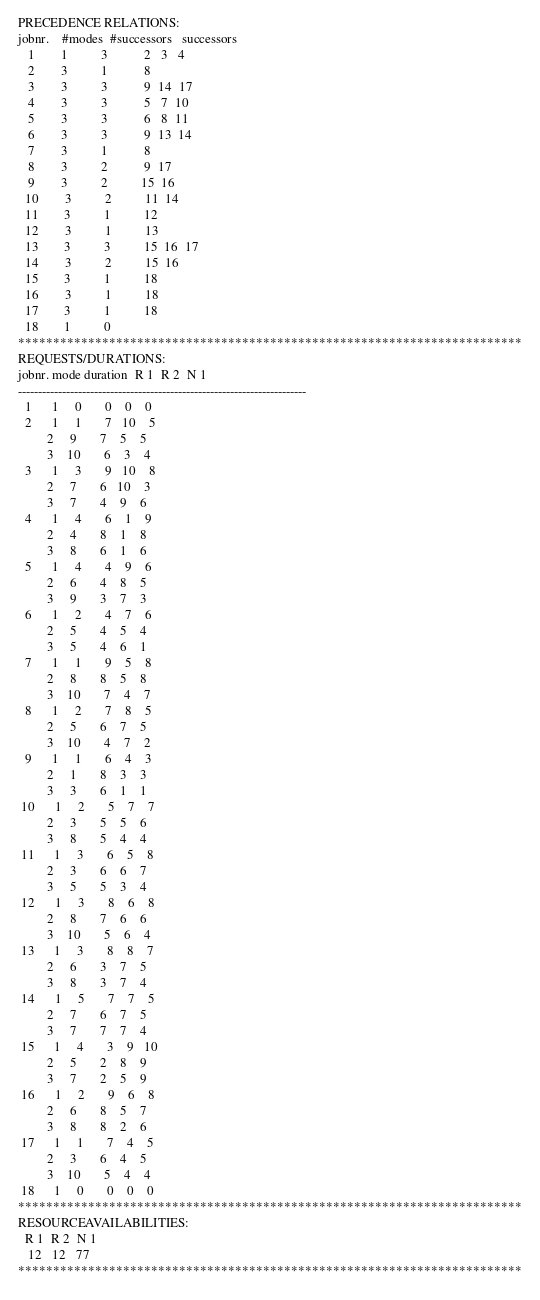<code> <loc_0><loc_0><loc_500><loc_500><_ObjectiveC_>PRECEDENCE RELATIONS:
jobnr.    #modes  #successors   successors
   1        1          3           2   3   4
   2        3          1           8
   3        3          3           9  14  17
   4        3          3           5   7  10
   5        3          3           6   8  11
   6        3          3           9  13  14
   7        3          1           8
   8        3          2           9  17
   9        3          2          15  16
  10        3          2          11  14
  11        3          1          12
  12        3          1          13
  13        3          3          15  16  17
  14        3          2          15  16
  15        3          1          18
  16        3          1          18
  17        3          1          18
  18        1          0        
************************************************************************
REQUESTS/DURATIONS:
jobnr. mode duration  R 1  R 2  N 1
------------------------------------------------------------------------
  1      1     0       0    0    0
  2      1     1       7   10    5
         2     9       7    5    5
         3    10       6    3    4
  3      1     3       9   10    8
         2     7       6   10    3
         3     7       4    9    6
  4      1     4       6    1    9
         2     4       8    1    8
         3     8       6    1    6
  5      1     4       4    9    6
         2     6       4    8    5
         3     9       3    7    3
  6      1     2       4    7    6
         2     5       4    5    4
         3     5       4    6    1
  7      1     1       9    5    8
         2     8       8    5    8
         3    10       7    4    7
  8      1     2       7    8    5
         2     5       6    7    5
         3    10       4    7    2
  9      1     1       6    4    3
         2     1       8    3    3
         3     3       6    1    1
 10      1     2       5    7    7
         2     3       5    5    6
         3     8       5    4    4
 11      1     3       6    5    8
         2     3       6    6    7
         3     5       5    3    4
 12      1     3       8    6    8
         2     8       7    6    6
         3    10       5    6    4
 13      1     3       8    8    7
         2     6       3    7    5
         3     8       3    7    4
 14      1     5       7    7    5
         2     7       6    7    5
         3     7       7    7    4
 15      1     4       3    9   10
         2     5       2    8    9
         3     7       2    5    9
 16      1     2       9    6    8
         2     6       8    5    7
         3     8       8    2    6
 17      1     1       7    4    5
         2     3       6    4    5
         3    10       5    4    4
 18      1     0       0    0    0
************************************************************************
RESOURCEAVAILABILITIES:
  R 1  R 2  N 1
   12   12   77
************************************************************************
</code> 